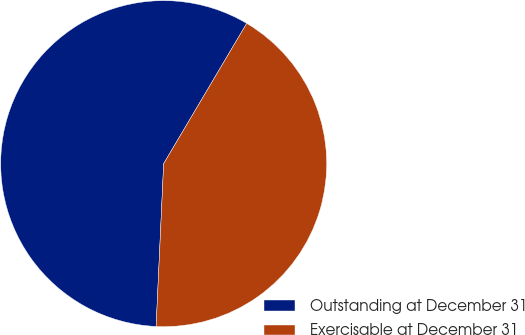<chart> <loc_0><loc_0><loc_500><loc_500><pie_chart><fcel>Outstanding at December 31<fcel>Exercisable at December 31<nl><fcel>57.77%<fcel>42.23%<nl></chart> 